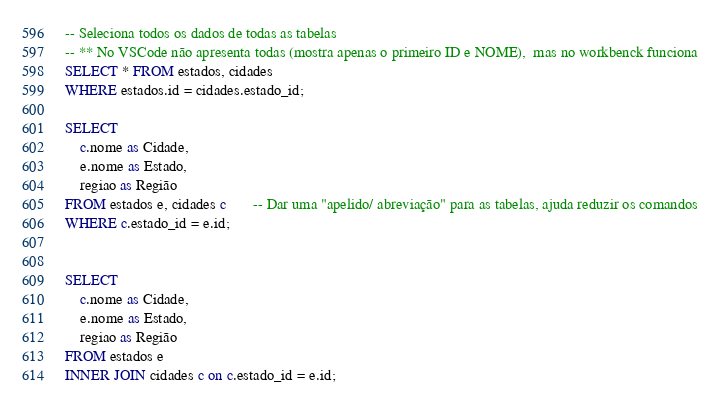Convert code to text. <code><loc_0><loc_0><loc_500><loc_500><_SQL_>-- Seleciona todos os dados de todas as tabelas 
-- ** No VSCode não apresenta todas (mostra apenas o primeiro ID e NOME),  mas no workbenck funciona
SELECT * FROM estados, cidades
WHERE estados.id = cidades.estado_id;

SELECT 
    c.nome as Cidade,
    e.nome as Estado,
    regiao as Região
FROM estados e, cidades c       -- Dar uma "apelido/ abreviação" para as tabelas, ajuda reduzir os comandos
WHERE c.estado_id = e.id;


SELECT 
    c.nome as Cidade,
    e.nome as Estado,
    regiao as Região
FROM estados e
INNER JOIN cidades c on c.estado_id = e.id;</code> 